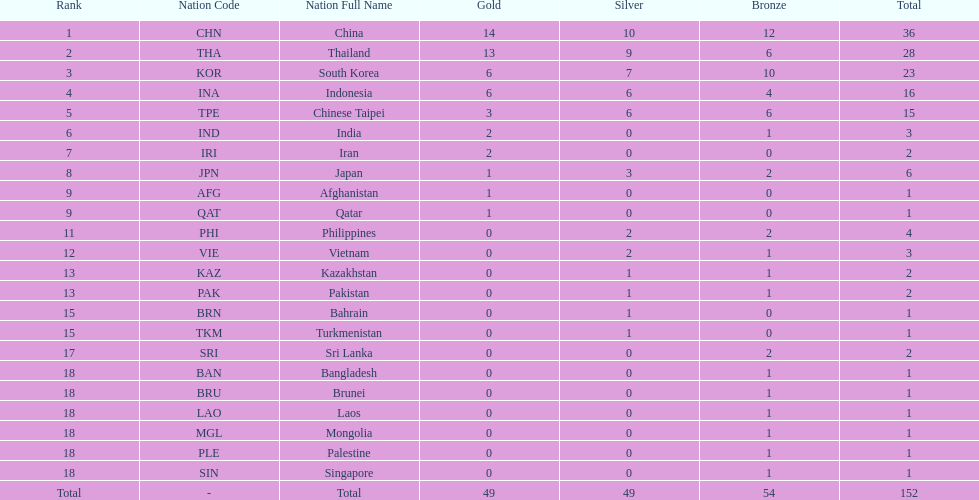How many nations received a medal in each gold, silver, and bronze? 6. 